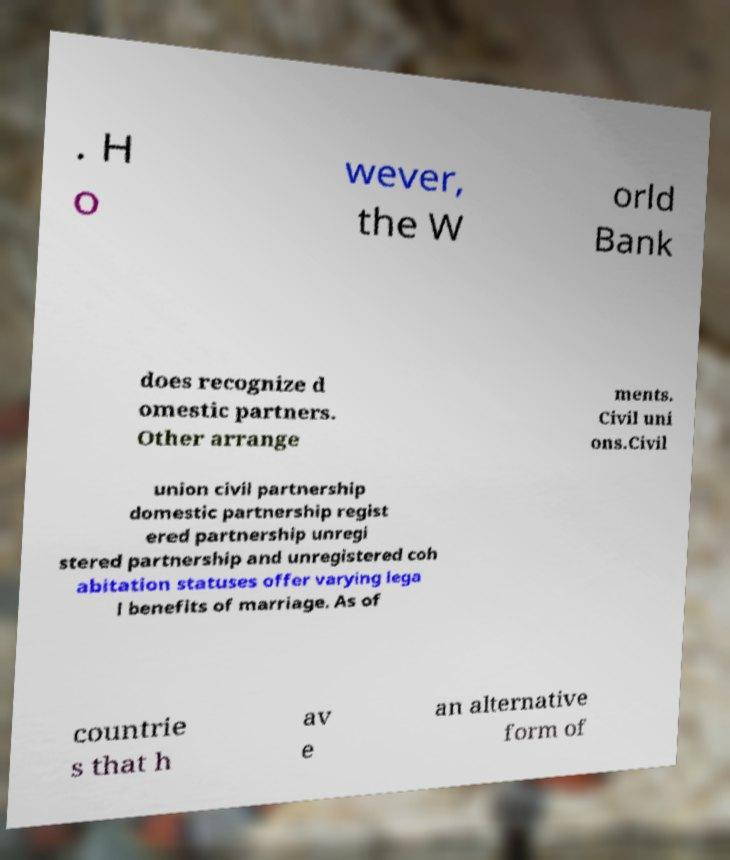Please read and relay the text visible in this image. What does it say? . H o wever, the W orld Bank does recognize d omestic partners. Other arrange ments. Civil uni ons.Civil union civil partnership domestic partnership regist ered partnership unregi stered partnership and unregistered coh abitation statuses offer varying lega l benefits of marriage. As of countrie s that h av e an alternative form of 